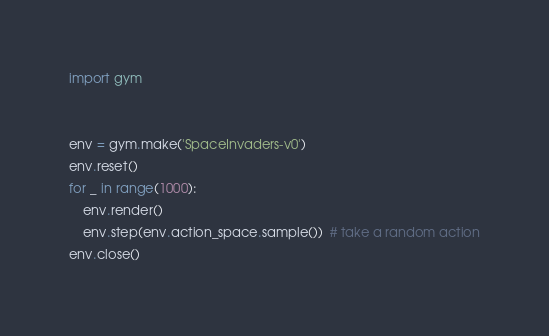Convert code to text. <code><loc_0><loc_0><loc_500><loc_500><_Python_>import gym


env = gym.make('SpaceInvaders-v0')
env.reset()
for _ in range(1000):
    env.render()
    env.step(env.action_space.sample())  # take a random action
env.close()
</code> 